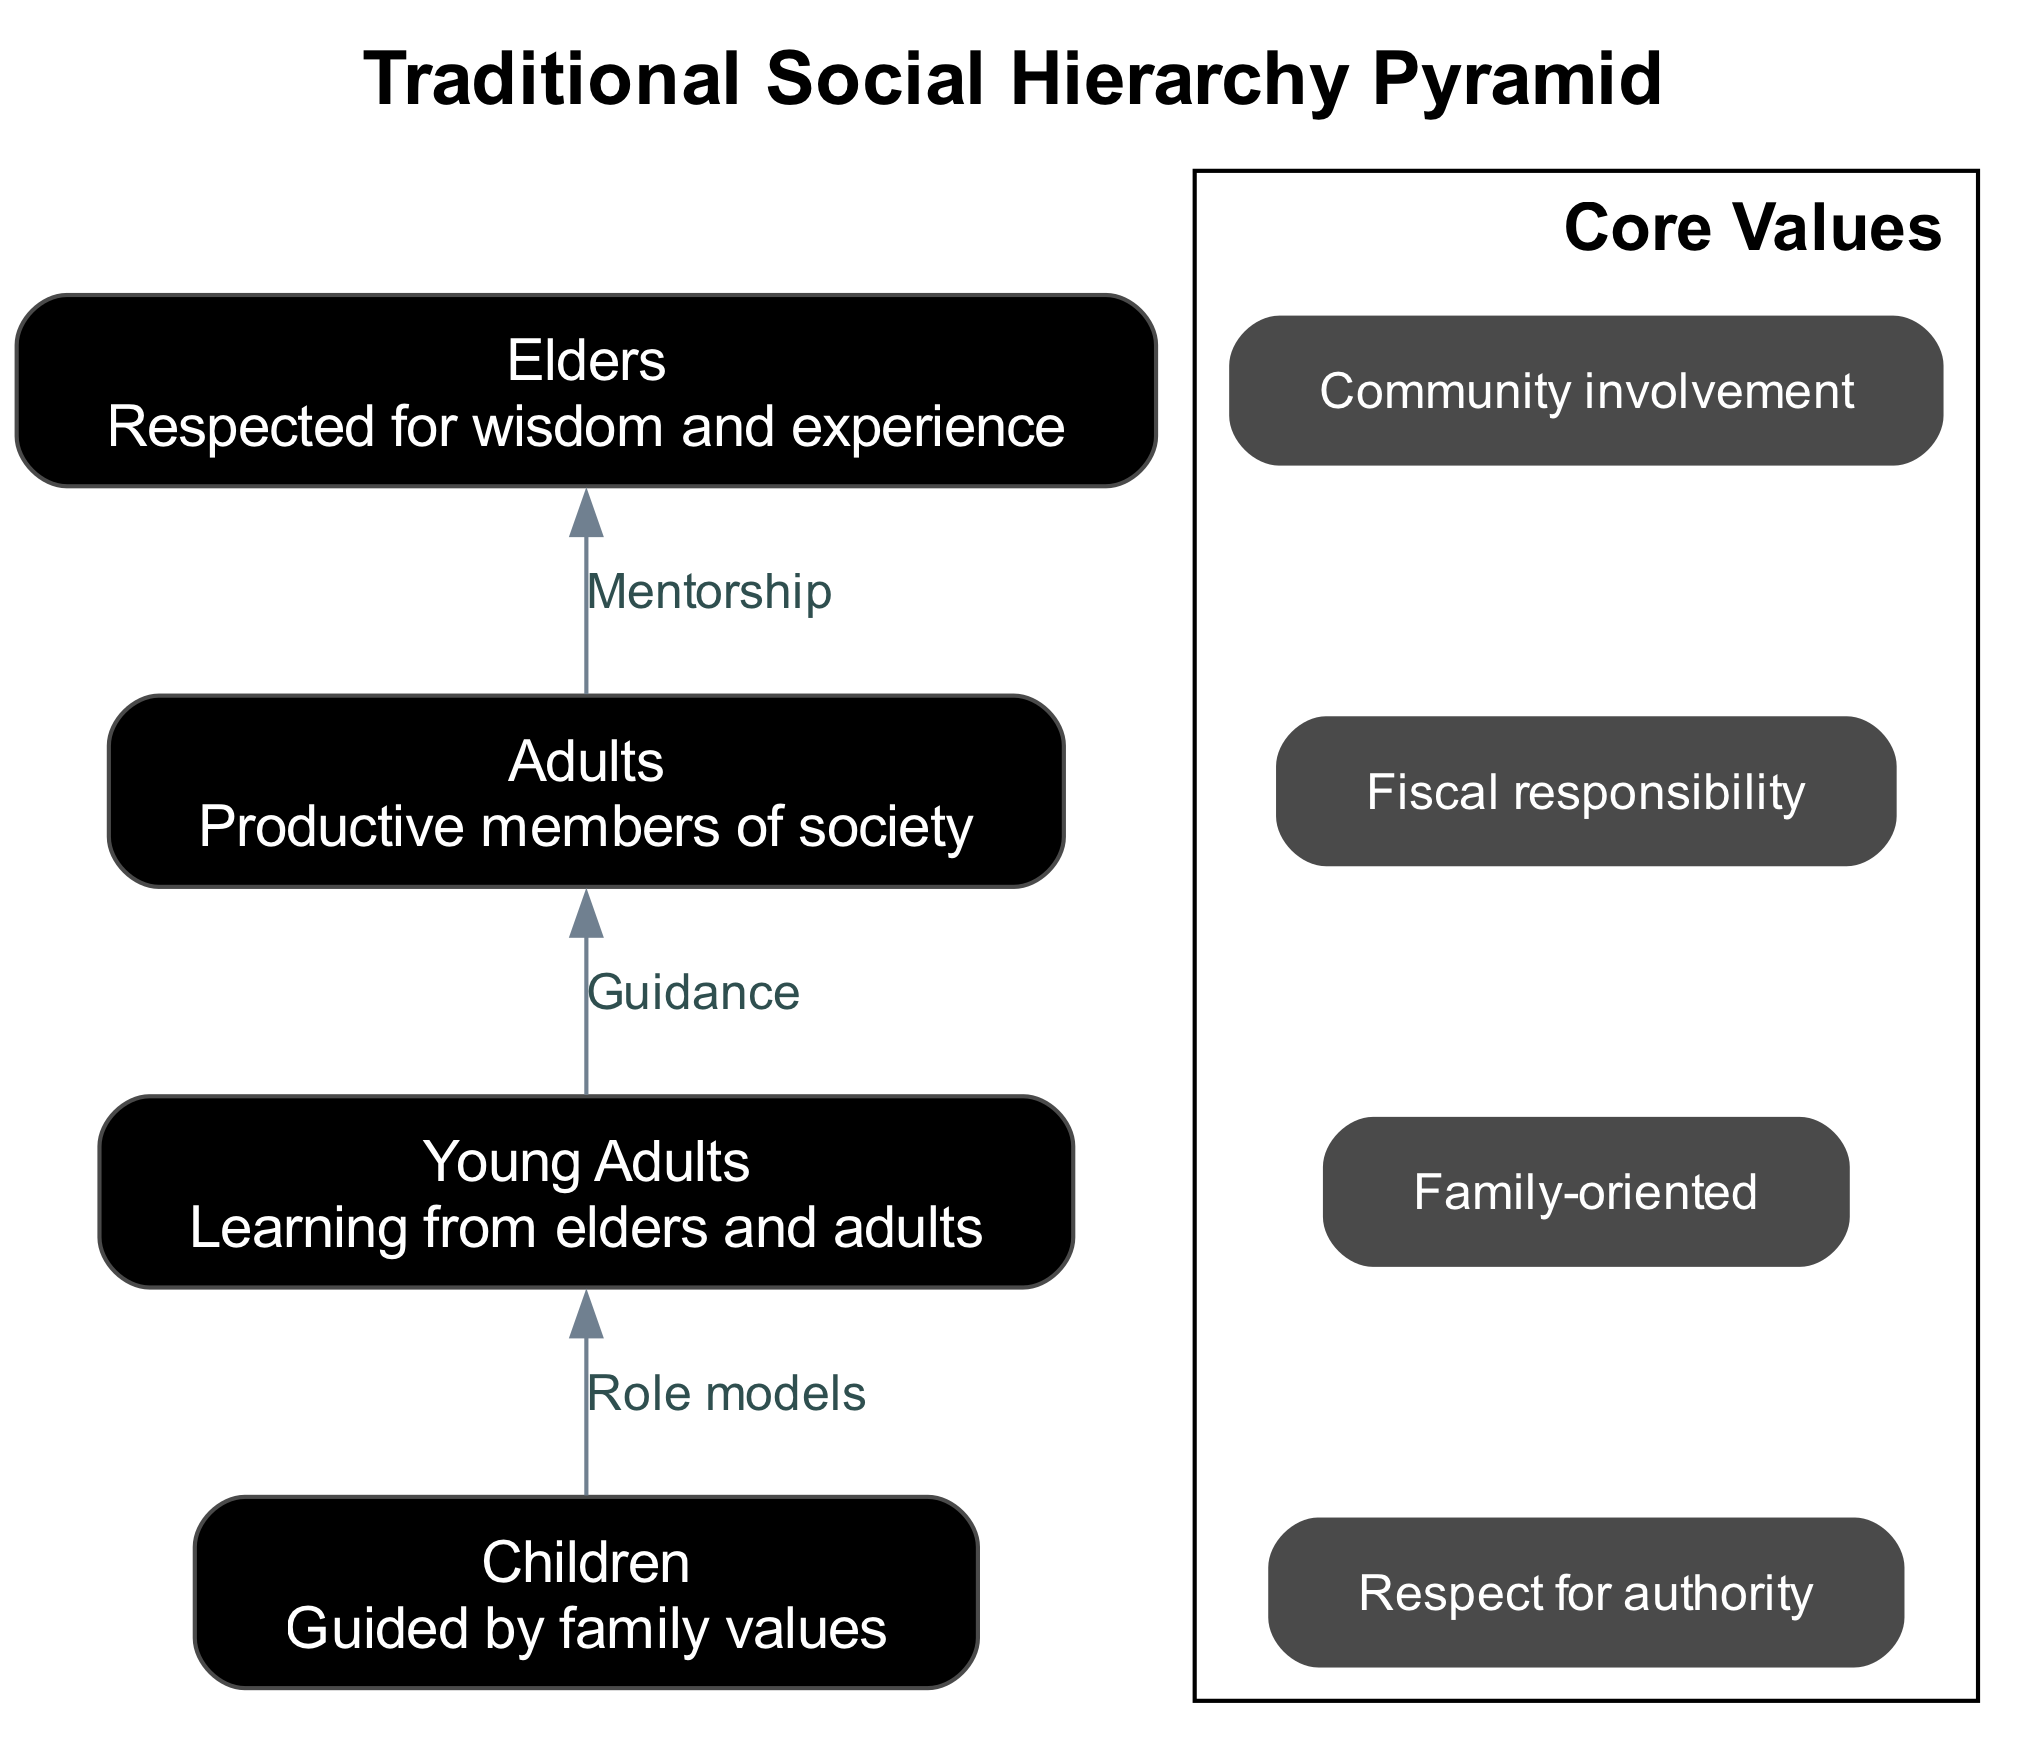What is the top level of the pyramid? The top level of the pyramid represents "Elders," which is the highest position in the hierarchy, signifying their importance in society.
Answer: Elders How many levels are in the social hierarchy pyramid? The diagram contains four distinct levels, each representing a different social group.
Answer: 4 What value is associated with the social hierarchy? The core values listed include respect for authority, family-oriented, fiscal responsibility, and community involvement. The first value mentioned is the answer.
Answer: Respect for authority What relationship exists between "Elders" and "Adults"? The diagram indicates a mentorship connection from "Elders" to "Adults," illustrating how elders guide and support the adults in society.
Answer: Mentorship Which level learns from the "Adults"? The "Young Adults" level is depicted as learning from "Adults," showing the transmission of knowledge and values.
Answer: Young Adults What is the primary role of "Children" in this hierarchy? "Children" are described as being guided by family values, emphasizing the influence of family in their upbringing.
Answer: Guided by family values How many core values are listed in the diagram? The diagram identifies four core values, representing fundamental beliefs and principles important to the social structure.
Answer: 4 Who are the role models for "Children"? The diagram specifies that "Young Adults" serve as role models for "Children," indicating a relationship where young adults influence the next generation.
Answer: Young Adults What connects "Young Adults" to "Children"? The relationship identified in the diagram is described as role models, highlighting how young adults act as examples for younger children to emulate.
Answer: Role models 